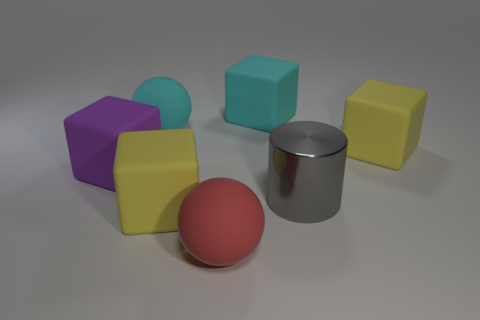Is there anything else that is the same shape as the gray shiny object?
Ensure brevity in your answer.  No. Do the yellow cube in front of the metal thing and the big gray cylinder right of the red thing have the same material?
Provide a short and direct response. No. There is a sphere that is the same size as the red matte object; what is its color?
Give a very brief answer. Cyan. Is there a cyan thing that has the same material as the big cyan cube?
Your answer should be very brief. Yes. Are there fewer large yellow matte things that are in front of the large gray cylinder than blue objects?
Give a very brief answer. No. There is a matte object on the right side of the gray cylinder; does it have the same size as the metallic cylinder?
Give a very brief answer. Yes. What number of yellow matte things are the same shape as the purple rubber thing?
Keep it short and to the point. 2. The cyan cube that is the same material as the purple cube is what size?
Offer a terse response. Large. Are there the same number of red balls that are on the right side of the gray shiny object and big rubber blocks?
Your answer should be very brief. No. Is the shape of the yellow object that is to the right of the big cylinder the same as the big yellow object to the left of the big cyan rubber cube?
Provide a succinct answer. Yes. 